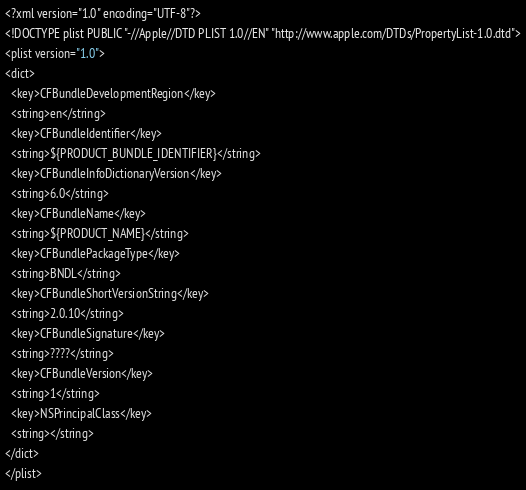Convert code to text. <code><loc_0><loc_0><loc_500><loc_500><_XML_><?xml version="1.0" encoding="UTF-8"?>
<!DOCTYPE plist PUBLIC "-//Apple//DTD PLIST 1.0//EN" "http://www.apple.com/DTDs/PropertyList-1.0.dtd">
<plist version="1.0">
<dict>
  <key>CFBundleDevelopmentRegion</key>
  <string>en</string>
  <key>CFBundleIdentifier</key>
  <string>${PRODUCT_BUNDLE_IDENTIFIER}</string>
  <key>CFBundleInfoDictionaryVersion</key>
  <string>6.0</string>
  <key>CFBundleName</key>
  <string>${PRODUCT_NAME}</string>
  <key>CFBundlePackageType</key>
  <string>BNDL</string>
  <key>CFBundleShortVersionString</key>
  <string>2.0.10</string>
  <key>CFBundleSignature</key>
  <string>????</string>
  <key>CFBundleVersion</key>
  <string>1</string>
  <key>NSPrincipalClass</key>
  <string></string>
</dict>
</plist>
</code> 